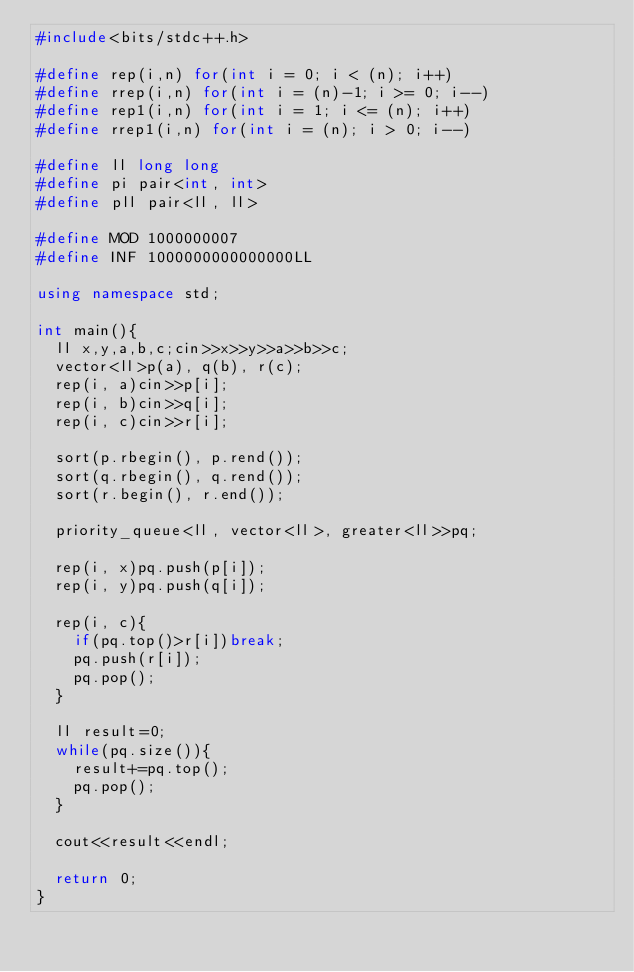<code> <loc_0><loc_0><loc_500><loc_500><_C++_>#include<bits/stdc++.h>

#define rep(i,n) for(int i = 0; i < (n); i++)
#define rrep(i,n) for(int i = (n)-1; i >= 0; i--)
#define rep1(i,n) for(int i = 1; i <= (n); i++)
#define rrep1(i,n) for(int i = (n); i > 0; i--)

#define ll long long
#define pi pair<int, int>
#define pll pair<ll, ll>

#define MOD 1000000007
#define INF 1000000000000000LL

using namespace std;

int main(){
  ll x,y,a,b,c;cin>>x>>y>>a>>b>>c;
  vector<ll>p(a), q(b), r(c);
  rep(i, a)cin>>p[i];
  rep(i, b)cin>>q[i];
  rep(i, c)cin>>r[i];

  sort(p.rbegin(), p.rend());
  sort(q.rbegin(), q.rend());
  sort(r.begin(), r.end());

  priority_queue<ll, vector<ll>, greater<ll>>pq;

  rep(i, x)pq.push(p[i]);
  rep(i, y)pq.push(q[i]);

  rep(i, c){
    if(pq.top()>r[i])break;
    pq.push(r[i]);
    pq.pop();
  }

  ll result=0;
  while(pq.size()){
    result+=pq.top();
    pq.pop();
  }

  cout<<result<<endl;

  return 0;
}</code> 